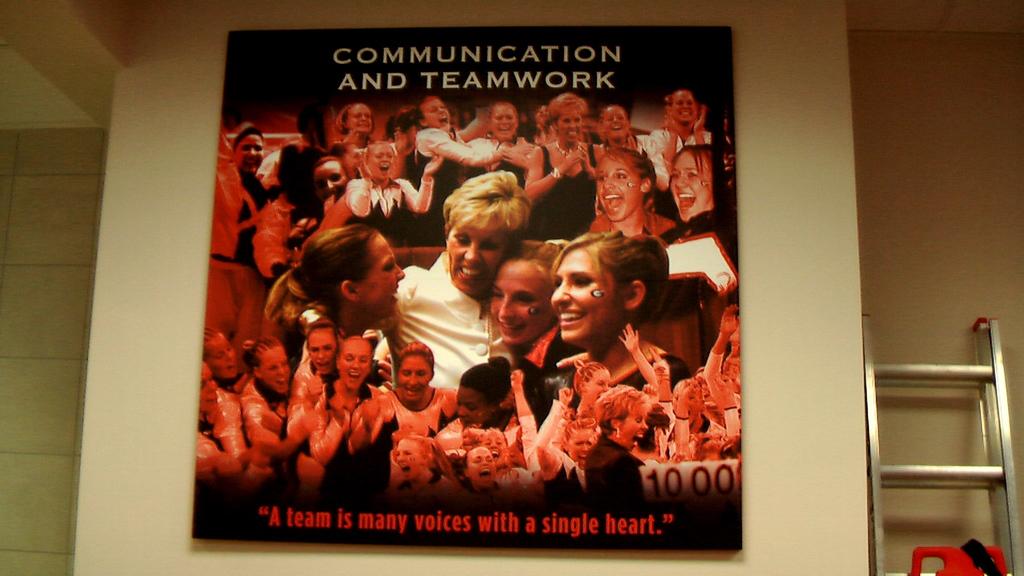What is the poster about?
Your answer should be compact. Communication and teamwork. A team is many voices with how many hearts?
Ensure brevity in your answer.  Single. 